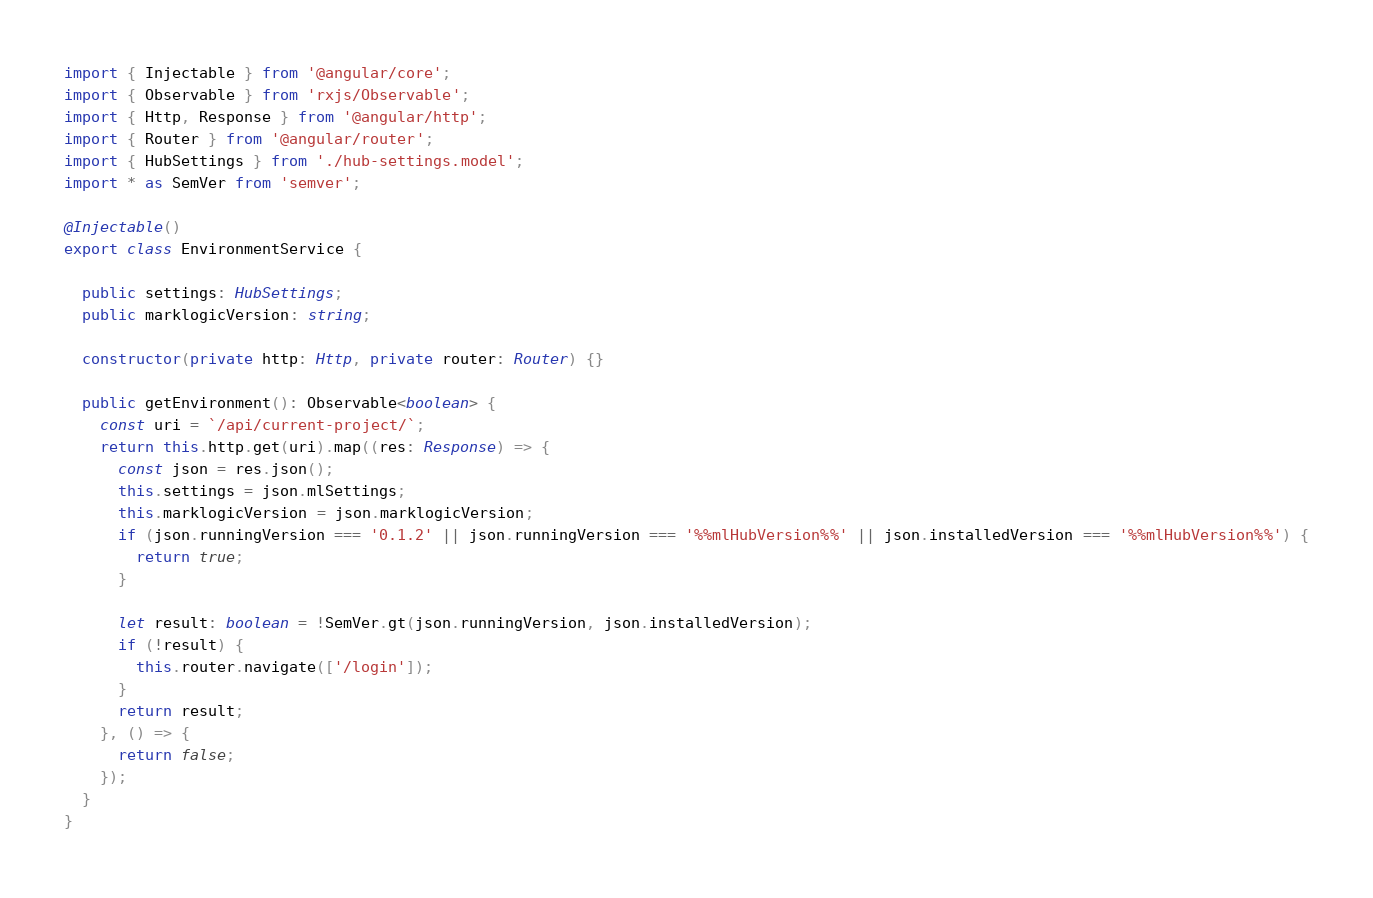<code> <loc_0><loc_0><loc_500><loc_500><_TypeScript_>import { Injectable } from '@angular/core';
import { Observable } from 'rxjs/Observable';
import { Http, Response } from '@angular/http';
import { Router } from '@angular/router';
import { HubSettings } from './hub-settings.model';
import * as SemVer from 'semver';

@Injectable()
export class EnvironmentService {

  public settings: HubSettings;
  public marklogicVersion: string;

  constructor(private http: Http, private router: Router) {}

  public getEnvironment(): Observable<boolean> {
    const uri = `/api/current-project/`;
    return this.http.get(uri).map((res: Response) => {
      const json = res.json();
      this.settings = json.mlSettings;
      this.marklogicVersion = json.marklogicVersion;
      if (json.runningVersion === '0.1.2' || json.runningVersion === '%%mlHubVersion%%' || json.installedVersion === '%%mlHubVersion%%') {
        return true;
      }

      let result: boolean = !SemVer.gt(json.runningVersion, json.installedVersion);
      if (!result) {
        this.router.navigate(['/login']);
      }
      return result;
    }, () => {
      return false;
    });
  }
}
</code> 